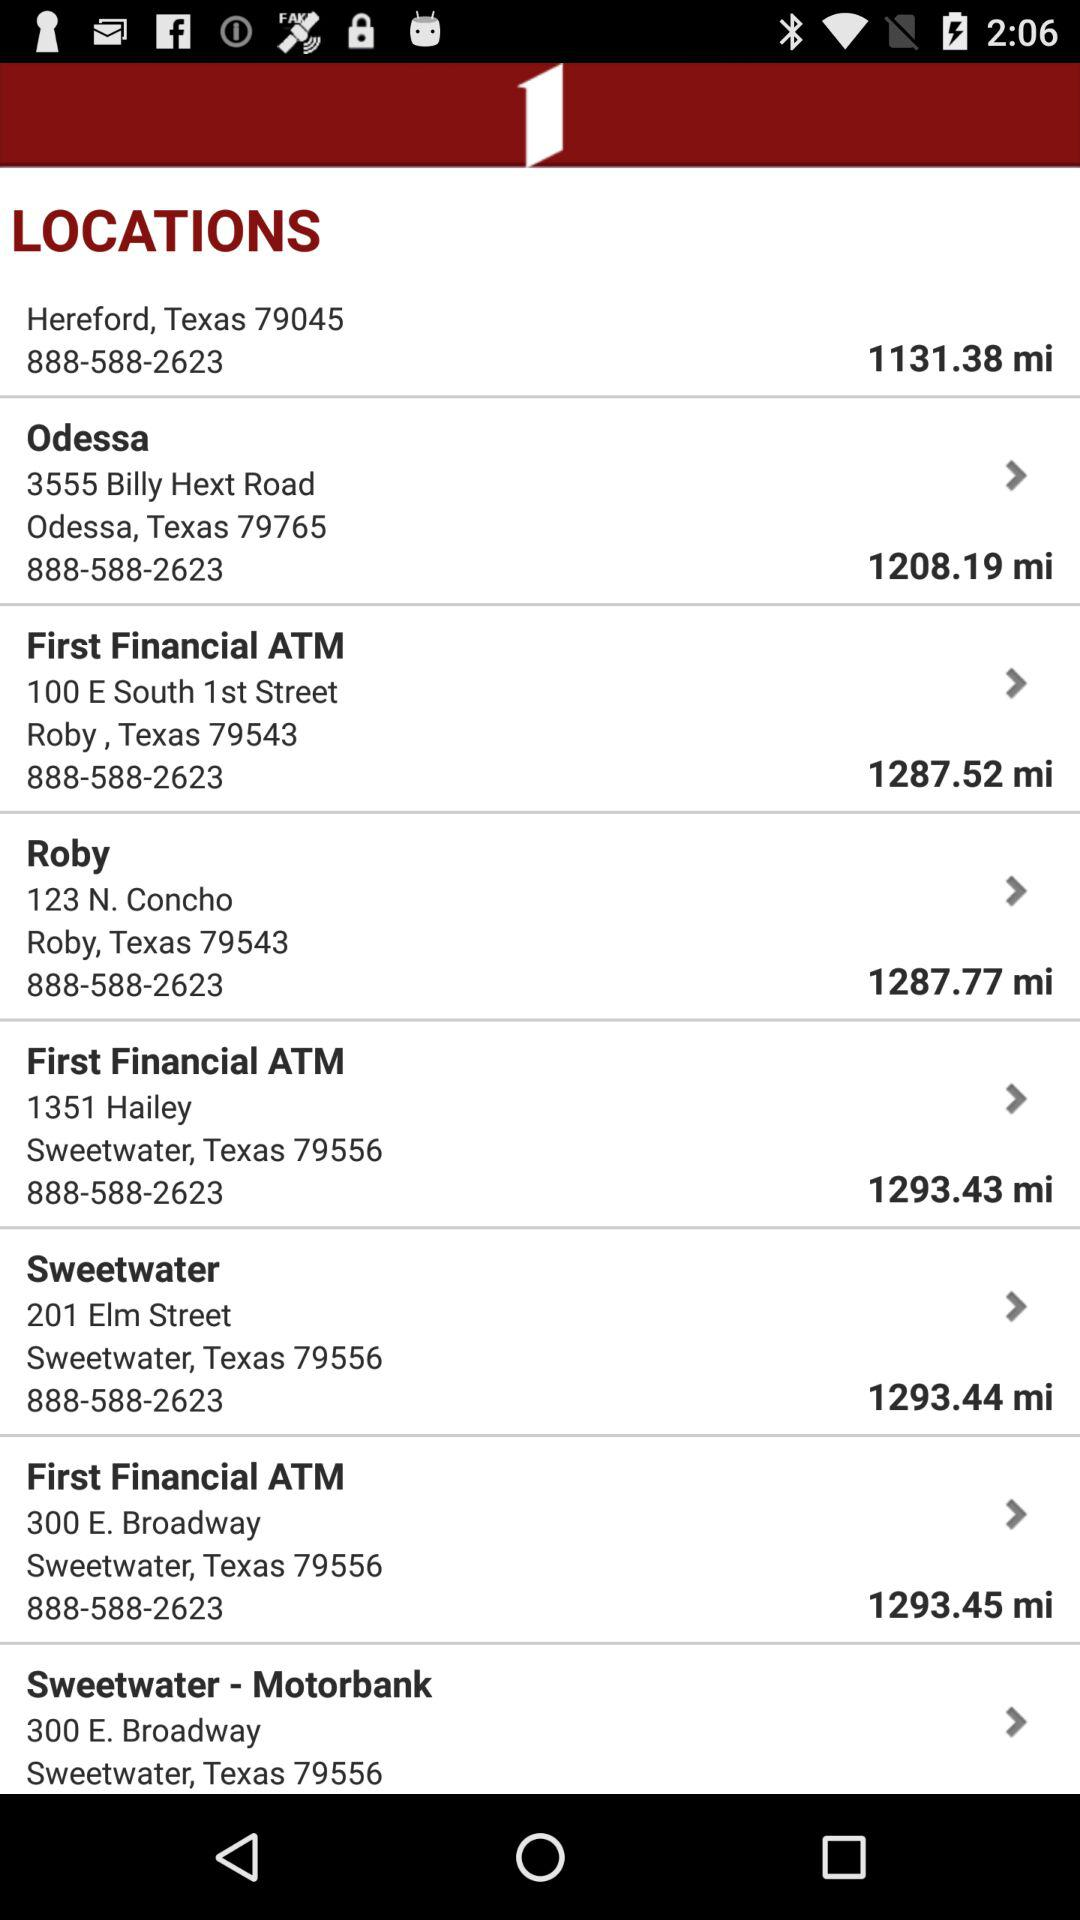How far away is Sweetwater Motorbank?
When the provided information is insufficient, respond with <no answer>. <no answer> 